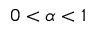<formula> <loc_0><loc_0><loc_500><loc_500>0 < \alpha < 1</formula> 